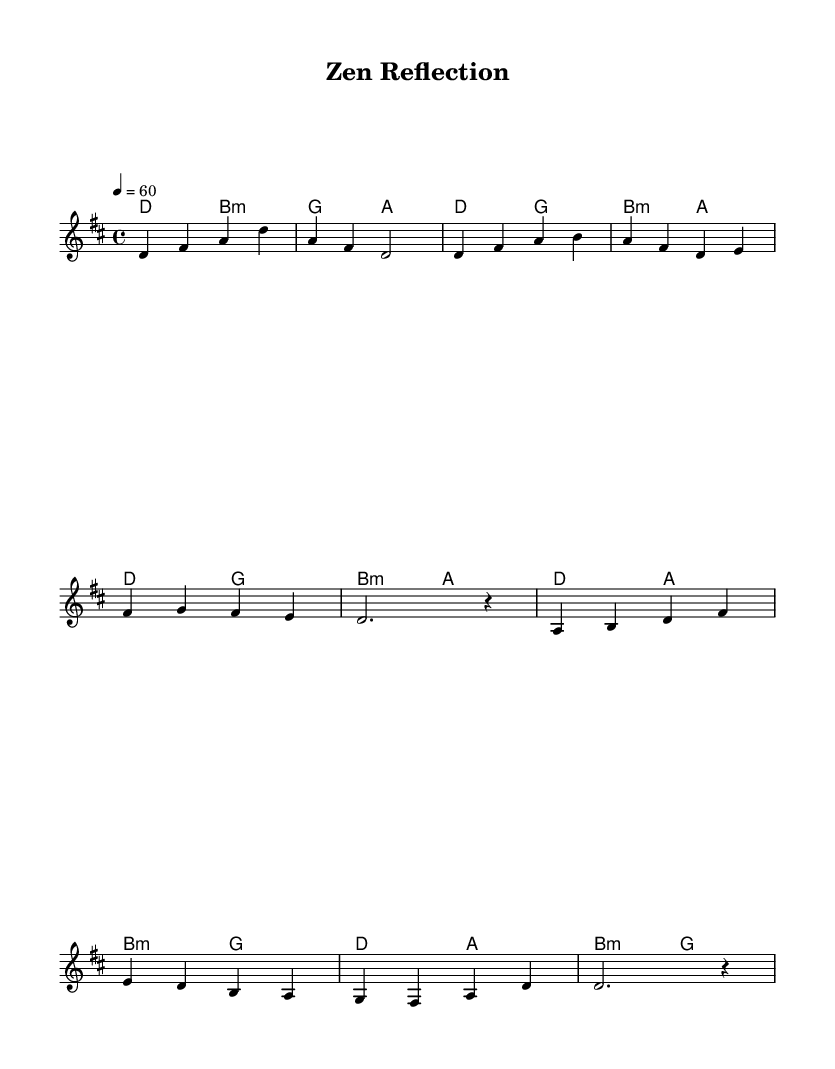What is the key signature of this music? The key signature indicates that it is in D major, which has two sharps (F# and C#). This is determined by looking at the key indicated in the global settings of the code.
Answer: D major What is the time signature of this piece? The time signature is shown as 4/4 in the global settings, which indicates there are four beats in a measure, and the quarter note gets one beat.
Answer: 4/4 What is the tempo marking for this piece? The tempo is set at 60 beats per minute, indicated by "4 = 60" in the global settings of the code. This means there are 60 quarter note beats per minute.
Answer: 60 How many measures are in the verse section? Counting the measures within the section labeled as the verse, there are four measures present, as each line consists of four beats organized into distinct measures.
Answer: 4 What chord follows the B minor chord in the chorus? In the transition from the chorus, after the B minor chord, the G major chord follows according to the chord progression displayed in the harmonies section.
Answer: G Which note is emphasized in the first melody line? The first melody line emphasizes the note D, as it is the starting note in the sequence played on the staff, making it the foundational tone of the piece.
Answer: D What is the overall mood suggested by the melody and harmonies? The combination of smooth melodic lines and rich harmonies suggests a mood of introspection and warmth, characteristic of soulful R&B ballads that explore themes of inner peace and self-reflection.
Answer: Soulful 